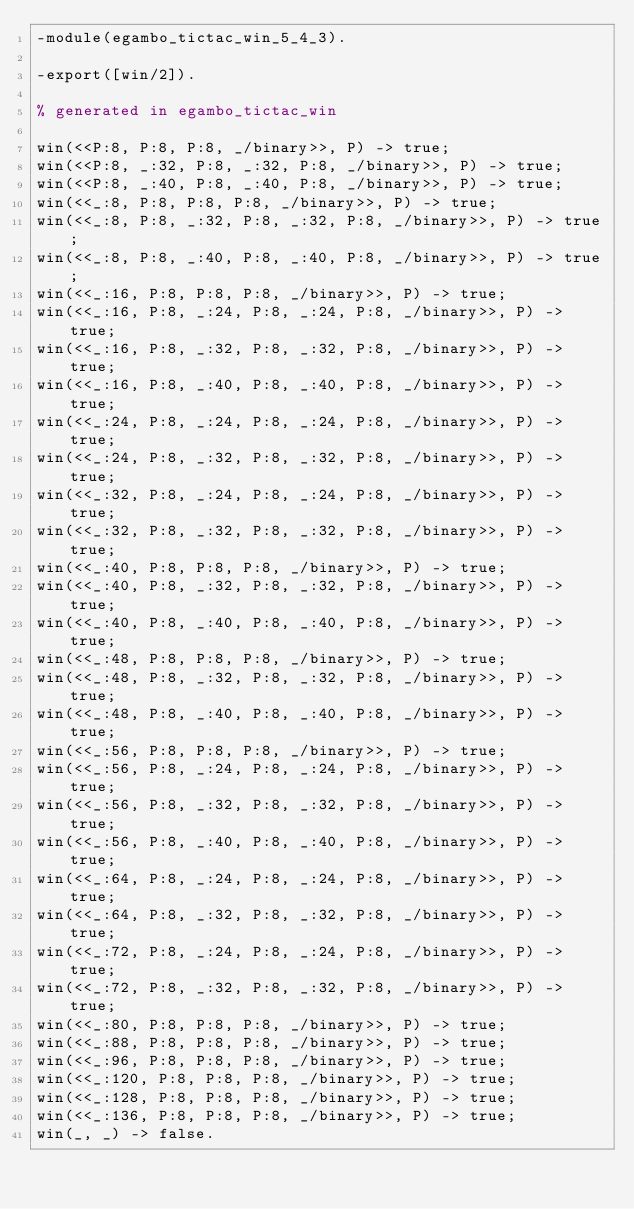<code> <loc_0><loc_0><loc_500><loc_500><_Erlang_>-module(egambo_tictac_win_5_4_3).

-export([win/2]).

% generated in egambo_tictac_win

win(<<P:8, P:8, P:8, _/binary>>, P) -> true;
win(<<P:8, _:32, P:8, _:32, P:8, _/binary>>, P) -> true;
win(<<P:8, _:40, P:8, _:40, P:8, _/binary>>, P) -> true;
win(<<_:8, P:8, P:8, P:8, _/binary>>, P) -> true;
win(<<_:8, P:8, _:32, P:8, _:32, P:8, _/binary>>, P) -> true;
win(<<_:8, P:8, _:40, P:8, _:40, P:8, _/binary>>, P) -> true;
win(<<_:16, P:8, P:8, P:8, _/binary>>, P) -> true;
win(<<_:16, P:8, _:24, P:8, _:24, P:8, _/binary>>, P) -> true;
win(<<_:16, P:8, _:32, P:8, _:32, P:8, _/binary>>, P) -> true;
win(<<_:16, P:8, _:40, P:8, _:40, P:8, _/binary>>, P) -> true;
win(<<_:24, P:8, _:24, P:8, _:24, P:8, _/binary>>, P) -> true;
win(<<_:24, P:8, _:32, P:8, _:32, P:8, _/binary>>, P) -> true;
win(<<_:32, P:8, _:24, P:8, _:24, P:8, _/binary>>, P) -> true;
win(<<_:32, P:8, _:32, P:8, _:32, P:8, _/binary>>, P) -> true;
win(<<_:40, P:8, P:8, P:8, _/binary>>, P) -> true;
win(<<_:40, P:8, _:32, P:8, _:32, P:8, _/binary>>, P) -> true;
win(<<_:40, P:8, _:40, P:8, _:40, P:8, _/binary>>, P) -> true;
win(<<_:48, P:8, P:8, P:8, _/binary>>, P) -> true;
win(<<_:48, P:8, _:32, P:8, _:32, P:8, _/binary>>, P) -> true;
win(<<_:48, P:8, _:40, P:8, _:40, P:8, _/binary>>, P) -> true;
win(<<_:56, P:8, P:8, P:8, _/binary>>, P) -> true;
win(<<_:56, P:8, _:24, P:8, _:24, P:8, _/binary>>, P) -> true;
win(<<_:56, P:8, _:32, P:8, _:32, P:8, _/binary>>, P) -> true;
win(<<_:56, P:8, _:40, P:8, _:40, P:8, _/binary>>, P) -> true;
win(<<_:64, P:8, _:24, P:8, _:24, P:8, _/binary>>, P) -> true;
win(<<_:64, P:8, _:32, P:8, _:32, P:8, _/binary>>, P) -> true;
win(<<_:72, P:8, _:24, P:8, _:24, P:8, _/binary>>, P) -> true;
win(<<_:72, P:8, _:32, P:8, _:32, P:8, _/binary>>, P) -> true;
win(<<_:80, P:8, P:8, P:8, _/binary>>, P) -> true;
win(<<_:88, P:8, P:8, P:8, _/binary>>, P) -> true;
win(<<_:96, P:8, P:8, P:8, _/binary>>, P) -> true;
win(<<_:120, P:8, P:8, P:8, _/binary>>, P) -> true;
win(<<_:128, P:8, P:8, P:8, _/binary>>, P) -> true;
win(<<_:136, P:8, P:8, P:8, _/binary>>, P) -> true;
win(_, _) -> false.

</code> 